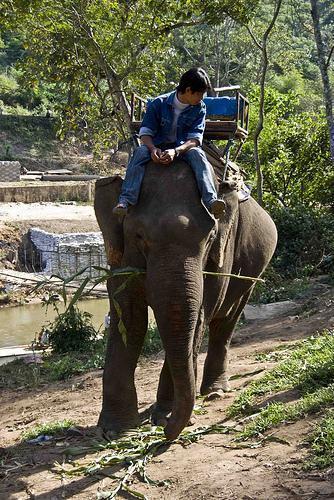How many women are on the elephant?
Give a very brief answer. 0. 